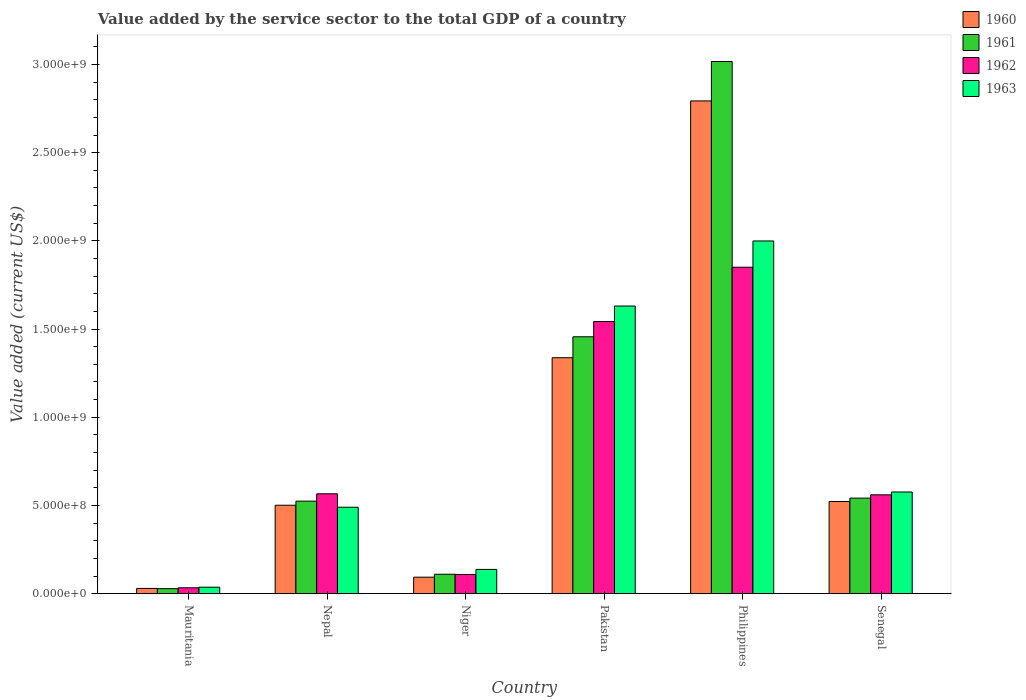How many different coloured bars are there?
Your response must be concise. 4. How many groups of bars are there?
Make the answer very short. 6. Are the number of bars per tick equal to the number of legend labels?
Your response must be concise. Yes. Are the number of bars on each tick of the X-axis equal?
Keep it short and to the point. Yes. How many bars are there on the 2nd tick from the right?
Ensure brevity in your answer.  4. In how many cases, is the number of bars for a given country not equal to the number of legend labels?
Ensure brevity in your answer.  0. What is the value added by the service sector to the total GDP in 1963 in Senegal?
Your answer should be very brief. 5.76e+08. Across all countries, what is the maximum value added by the service sector to the total GDP in 1961?
Ensure brevity in your answer.  3.02e+09. Across all countries, what is the minimum value added by the service sector to the total GDP in 1960?
Offer a terse response. 2.97e+07. In which country was the value added by the service sector to the total GDP in 1963 maximum?
Offer a very short reply. Philippines. In which country was the value added by the service sector to the total GDP in 1962 minimum?
Offer a terse response. Mauritania. What is the total value added by the service sector to the total GDP in 1962 in the graph?
Ensure brevity in your answer.  4.66e+09. What is the difference between the value added by the service sector to the total GDP in 1961 in Nepal and that in Niger?
Your answer should be compact. 4.14e+08. What is the difference between the value added by the service sector to the total GDP in 1961 in Philippines and the value added by the service sector to the total GDP in 1960 in Mauritania?
Provide a short and direct response. 2.99e+09. What is the average value added by the service sector to the total GDP in 1960 per country?
Offer a terse response. 8.80e+08. What is the difference between the value added by the service sector to the total GDP of/in 1960 and value added by the service sector to the total GDP of/in 1961 in Philippines?
Provide a short and direct response. -2.24e+08. In how many countries, is the value added by the service sector to the total GDP in 1962 greater than 1900000000 US$?
Keep it short and to the point. 0. What is the ratio of the value added by the service sector to the total GDP in 1960 in Mauritania to that in Philippines?
Offer a terse response. 0.01. Is the value added by the service sector to the total GDP in 1960 in Mauritania less than that in Nepal?
Keep it short and to the point. Yes. Is the difference between the value added by the service sector to the total GDP in 1960 in Niger and Pakistan greater than the difference between the value added by the service sector to the total GDP in 1961 in Niger and Pakistan?
Give a very brief answer. Yes. What is the difference between the highest and the second highest value added by the service sector to the total GDP in 1962?
Give a very brief answer. 1.28e+09. What is the difference between the highest and the lowest value added by the service sector to the total GDP in 1963?
Your answer should be compact. 1.96e+09. In how many countries, is the value added by the service sector to the total GDP in 1961 greater than the average value added by the service sector to the total GDP in 1961 taken over all countries?
Offer a very short reply. 2. Is the sum of the value added by the service sector to the total GDP in 1963 in Mauritania and Nepal greater than the maximum value added by the service sector to the total GDP in 1960 across all countries?
Your answer should be very brief. No. What does the 3rd bar from the right in Philippines represents?
Make the answer very short. 1961. Is it the case that in every country, the sum of the value added by the service sector to the total GDP in 1960 and value added by the service sector to the total GDP in 1961 is greater than the value added by the service sector to the total GDP in 1962?
Give a very brief answer. Yes. How many bars are there?
Provide a succinct answer. 24. Are all the bars in the graph horizontal?
Offer a terse response. No. How many countries are there in the graph?
Your answer should be compact. 6. What is the difference between two consecutive major ticks on the Y-axis?
Give a very brief answer. 5.00e+08. Are the values on the major ticks of Y-axis written in scientific E-notation?
Offer a very short reply. Yes. Does the graph contain grids?
Provide a succinct answer. No. What is the title of the graph?
Keep it short and to the point. Value added by the service sector to the total GDP of a country. Does "1988" appear as one of the legend labels in the graph?
Keep it short and to the point. No. What is the label or title of the Y-axis?
Ensure brevity in your answer.  Value added (current US$). What is the Value added (current US$) in 1960 in Mauritania?
Provide a short and direct response. 2.97e+07. What is the Value added (current US$) in 1961 in Mauritania?
Your answer should be very brief. 2.83e+07. What is the Value added (current US$) of 1962 in Mauritania?
Your answer should be compact. 3.32e+07. What is the Value added (current US$) in 1963 in Mauritania?
Ensure brevity in your answer.  3.67e+07. What is the Value added (current US$) of 1960 in Nepal?
Ensure brevity in your answer.  5.01e+08. What is the Value added (current US$) in 1961 in Nepal?
Provide a succinct answer. 5.25e+08. What is the Value added (current US$) of 1962 in Nepal?
Your response must be concise. 5.66e+08. What is the Value added (current US$) in 1963 in Nepal?
Give a very brief answer. 4.90e+08. What is the Value added (current US$) of 1960 in Niger?
Make the answer very short. 9.35e+07. What is the Value added (current US$) in 1961 in Niger?
Offer a terse response. 1.10e+08. What is the Value added (current US$) in 1962 in Niger?
Provide a short and direct response. 1.09e+08. What is the Value added (current US$) in 1963 in Niger?
Give a very brief answer. 1.37e+08. What is the Value added (current US$) of 1960 in Pakistan?
Make the answer very short. 1.34e+09. What is the Value added (current US$) of 1961 in Pakistan?
Keep it short and to the point. 1.46e+09. What is the Value added (current US$) of 1962 in Pakistan?
Your answer should be compact. 1.54e+09. What is the Value added (current US$) in 1963 in Pakistan?
Give a very brief answer. 1.63e+09. What is the Value added (current US$) in 1960 in Philippines?
Your answer should be very brief. 2.79e+09. What is the Value added (current US$) in 1961 in Philippines?
Offer a very short reply. 3.02e+09. What is the Value added (current US$) in 1962 in Philippines?
Provide a succinct answer. 1.85e+09. What is the Value added (current US$) of 1963 in Philippines?
Your answer should be compact. 2.00e+09. What is the Value added (current US$) of 1960 in Senegal?
Your answer should be very brief. 5.23e+08. What is the Value added (current US$) of 1961 in Senegal?
Make the answer very short. 5.42e+08. What is the Value added (current US$) in 1962 in Senegal?
Provide a succinct answer. 5.60e+08. What is the Value added (current US$) in 1963 in Senegal?
Your response must be concise. 5.76e+08. Across all countries, what is the maximum Value added (current US$) in 1960?
Offer a terse response. 2.79e+09. Across all countries, what is the maximum Value added (current US$) in 1961?
Your answer should be very brief. 3.02e+09. Across all countries, what is the maximum Value added (current US$) of 1962?
Make the answer very short. 1.85e+09. Across all countries, what is the maximum Value added (current US$) in 1963?
Your answer should be very brief. 2.00e+09. Across all countries, what is the minimum Value added (current US$) in 1960?
Give a very brief answer. 2.97e+07. Across all countries, what is the minimum Value added (current US$) of 1961?
Offer a very short reply. 2.83e+07. Across all countries, what is the minimum Value added (current US$) in 1962?
Keep it short and to the point. 3.32e+07. Across all countries, what is the minimum Value added (current US$) of 1963?
Your answer should be compact. 3.67e+07. What is the total Value added (current US$) in 1960 in the graph?
Your answer should be compact. 5.28e+09. What is the total Value added (current US$) of 1961 in the graph?
Your answer should be compact. 5.68e+09. What is the total Value added (current US$) in 1962 in the graph?
Make the answer very short. 4.66e+09. What is the total Value added (current US$) in 1963 in the graph?
Your answer should be compact. 4.87e+09. What is the difference between the Value added (current US$) of 1960 in Mauritania and that in Nepal?
Provide a short and direct response. -4.72e+08. What is the difference between the Value added (current US$) of 1961 in Mauritania and that in Nepal?
Provide a short and direct response. -4.96e+08. What is the difference between the Value added (current US$) of 1962 in Mauritania and that in Nepal?
Give a very brief answer. -5.33e+08. What is the difference between the Value added (current US$) of 1963 in Mauritania and that in Nepal?
Offer a very short reply. -4.53e+08. What is the difference between the Value added (current US$) of 1960 in Mauritania and that in Niger?
Ensure brevity in your answer.  -6.37e+07. What is the difference between the Value added (current US$) in 1961 in Mauritania and that in Niger?
Your answer should be compact. -8.18e+07. What is the difference between the Value added (current US$) in 1962 in Mauritania and that in Niger?
Your answer should be very brief. -7.57e+07. What is the difference between the Value added (current US$) of 1963 in Mauritania and that in Niger?
Your response must be concise. -1.01e+08. What is the difference between the Value added (current US$) of 1960 in Mauritania and that in Pakistan?
Offer a terse response. -1.31e+09. What is the difference between the Value added (current US$) in 1961 in Mauritania and that in Pakistan?
Provide a short and direct response. -1.43e+09. What is the difference between the Value added (current US$) in 1962 in Mauritania and that in Pakistan?
Your answer should be very brief. -1.51e+09. What is the difference between the Value added (current US$) in 1963 in Mauritania and that in Pakistan?
Offer a terse response. -1.59e+09. What is the difference between the Value added (current US$) of 1960 in Mauritania and that in Philippines?
Keep it short and to the point. -2.76e+09. What is the difference between the Value added (current US$) in 1961 in Mauritania and that in Philippines?
Your answer should be compact. -2.99e+09. What is the difference between the Value added (current US$) in 1962 in Mauritania and that in Philippines?
Give a very brief answer. -1.82e+09. What is the difference between the Value added (current US$) of 1963 in Mauritania and that in Philippines?
Offer a terse response. -1.96e+09. What is the difference between the Value added (current US$) of 1960 in Mauritania and that in Senegal?
Provide a succinct answer. -4.93e+08. What is the difference between the Value added (current US$) in 1961 in Mauritania and that in Senegal?
Your response must be concise. -5.13e+08. What is the difference between the Value added (current US$) of 1962 in Mauritania and that in Senegal?
Offer a very short reply. -5.27e+08. What is the difference between the Value added (current US$) in 1963 in Mauritania and that in Senegal?
Your answer should be compact. -5.40e+08. What is the difference between the Value added (current US$) of 1960 in Nepal and that in Niger?
Offer a very short reply. 4.08e+08. What is the difference between the Value added (current US$) of 1961 in Nepal and that in Niger?
Your answer should be very brief. 4.14e+08. What is the difference between the Value added (current US$) in 1962 in Nepal and that in Niger?
Give a very brief answer. 4.57e+08. What is the difference between the Value added (current US$) in 1963 in Nepal and that in Niger?
Make the answer very short. 3.53e+08. What is the difference between the Value added (current US$) in 1960 in Nepal and that in Pakistan?
Offer a terse response. -8.36e+08. What is the difference between the Value added (current US$) of 1961 in Nepal and that in Pakistan?
Your answer should be very brief. -9.32e+08. What is the difference between the Value added (current US$) of 1962 in Nepal and that in Pakistan?
Offer a very short reply. -9.77e+08. What is the difference between the Value added (current US$) in 1963 in Nepal and that in Pakistan?
Provide a succinct answer. -1.14e+09. What is the difference between the Value added (current US$) in 1960 in Nepal and that in Philippines?
Make the answer very short. -2.29e+09. What is the difference between the Value added (current US$) in 1961 in Nepal and that in Philippines?
Your answer should be compact. -2.49e+09. What is the difference between the Value added (current US$) in 1962 in Nepal and that in Philippines?
Make the answer very short. -1.28e+09. What is the difference between the Value added (current US$) in 1963 in Nepal and that in Philippines?
Ensure brevity in your answer.  -1.51e+09. What is the difference between the Value added (current US$) in 1960 in Nepal and that in Senegal?
Ensure brevity in your answer.  -2.14e+07. What is the difference between the Value added (current US$) in 1961 in Nepal and that in Senegal?
Your answer should be very brief. -1.70e+07. What is the difference between the Value added (current US$) in 1962 in Nepal and that in Senegal?
Ensure brevity in your answer.  5.71e+06. What is the difference between the Value added (current US$) in 1963 in Nepal and that in Senegal?
Offer a very short reply. -8.63e+07. What is the difference between the Value added (current US$) of 1960 in Niger and that in Pakistan?
Make the answer very short. -1.24e+09. What is the difference between the Value added (current US$) of 1961 in Niger and that in Pakistan?
Give a very brief answer. -1.35e+09. What is the difference between the Value added (current US$) of 1962 in Niger and that in Pakistan?
Offer a terse response. -1.43e+09. What is the difference between the Value added (current US$) of 1963 in Niger and that in Pakistan?
Offer a terse response. -1.49e+09. What is the difference between the Value added (current US$) in 1960 in Niger and that in Philippines?
Ensure brevity in your answer.  -2.70e+09. What is the difference between the Value added (current US$) of 1961 in Niger and that in Philippines?
Ensure brevity in your answer.  -2.91e+09. What is the difference between the Value added (current US$) in 1962 in Niger and that in Philippines?
Give a very brief answer. -1.74e+09. What is the difference between the Value added (current US$) of 1963 in Niger and that in Philippines?
Make the answer very short. -1.86e+09. What is the difference between the Value added (current US$) in 1960 in Niger and that in Senegal?
Your response must be concise. -4.29e+08. What is the difference between the Value added (current US$) of 1961 in Niger and that in Senegal?
Your answer should be compact. -4.32e+08. What is the difference between the Value added (current US$) in 1962 in Niger and that in Senegal?
Your answer should be very brief. -4.51e+08. What is the difference between the Value added (current US$) in 1963 in Niger and that in Senegal?
Provide a short and direct response. -4.39e+08. What is the difference between the Value added (current US$) in 1960 in Pakistan and that in Philippines?
Give a very brief answer. -1.46e+09. What is the difference between the Value added (current US$) in 1961 in Pakistan and that in Philippines?
Your answer should be very brief. -1.56e+09. What is the difference between the Value added (current US$) of 1962 in Pakistan and that in Philippines?
Offer a very short reply. -3.08e+08. What is the difference between the Value added (current US$) in 1963 in Pakistan and that in Philippines?
Offer a terse response. -3.69e+08. What is the difference between the Value added (current US$) of 1960 in Pakistan and that in Senegal?
Offer a terse response. 8.15e+08. What is the difference between the Value added (current US$) of 1961 in Pakistan and that in Senegal?
Ensure brevity in your answer.  9.15e+08. What is the difference between the Value added (current US$) in 1962 in Pakistan and that in Senegal?
Your answer should be very brief. 9.82e+08. What is the difference between the Value added (current US$) in 1963 in Pakistan and that in Senegal?
Your answer should be compact. 1.05e+09. What is the difference between the Value added (current US$) in 1960 in Philippines and that in Senegal?
Your answer should be compact. 2.27e+09. What is the difference between the Value added (current US$) in 1961 in Philippines and that in Senegal?
Ensure brevity in your answer.  2.48e+09. What is the difference between the Value added (current US$) in 1962 in Philippines and that in Senegal?
Make the answer very short. 1.29e+09. What is the difference between the Value added (current US$) of 1963 in Philippines and that in Senegal?
Your response must be concise. 1.42e+09. What is the difference between the Value added (current US$) of 1960 in Mauritania and the Value added (current US$) of 1961 in Nepal?
Provide a succinct answer. -4.95e+08. What is the difference between the Value added (current US$) in 1960 in Mauritania and the Value added (current US$) in 1962 in Nepal?
Your response must be concise. -5.36e+08. What is the difference between the Value added (current US$) of 1960 in Mauritania and the Value added (current US$) of 1963 in Nepal?
Your answer should be compact. -4.60e+08. What is the difference between the Value added (current US$) in 1961 in Mauritania and the Value added (current US$) in 1962 in Nepal?
Provide a succinct answer. -5.38e+08. What is the difference between the Value added (current US$) in 1961 in Mauritania and the Value added (current US$) in 1963 in Nepal?
Keep it short and to the point. -4.62e+08. What is the difference between the Value added (current US$) of 1962 in Mauritania and the Value added (current US$) of 1963 in Nepal?
Provide a short and direct response. -4.57e+08. What is the difference between the Value added (current US$) of 1960 in Mauritania and the Value added (current US$) of 1961 in Niger?
Make the answer very short. -8.04e+07. What is the difference between the Value added (current US$) of 1960 in Mauritania and the Value added (current US$) of 1962 in Niger?
Provide a short and direct response. -7.92e+07. What is the difference between the Value added (current US$) in 1960 in Mauritania and the Value added (current US$) in 1963 in Niger?
Your answer should be compact. -1.08e+08. What is the difference between the Value added (current US$) of 1961 in Mauritania and the Value added (current US$) of 1962 in Niger?
Offer a very short reply. -8.06e+07. What is the difference between the Value added (current US$) in 1961 in Mauritania and the Value added (current US$) in 1963 in Niger?
Provide a succinct answer. -1.09e+08. What is the difference between the Value added (current US$) of 1962 in Mauritania and the Value added (current US$) of 1963 in Niger?
Make the answer very short. -1.04e+08. What is the difference between the Value added (current US$) in 1960 in Mauritania and the Value added (current US$) in 1961 in Pakistan?
Offer a very short reply. -1.43e+09. What is the difference between the Value added (current US$) in 1960 in Mauritania and the Value added (current US$) in 1962 in Pakistan?
Keep it short and to the point. -1.51e+09. What is the difference between the Value added (current US$) in 1960 in Mauritania and the Value added (current US$) in 1963 in Pakistan?
Your response must be concise. -1.60e+09. What is the difference between the Value added (current US$) of 1961 in Mauritania and the Value added (current US$) of 1962 in Pakistan?
Ensure brevity in your answer.  -1.51e+09. What is the difference between the Value added (current US$) of 1961 in Mauritania and the Value added (current US$) of 1963 in Pakistan?
Give a very brief answer. -1.60e+09. What is the difference between the Value added (current US$) of 1962 in Mauritania and the Value added (current US$) of 1963 in Pakistan?
Offer a very short reply. -1.60e+09. What is the difference between the Value added (current US$) of 1960 in Mauritania and the Value added (current US$) of 1961 in Philippines?
Your answer should be compact. -2.99e+09. What is the difference between the Value added (current US$) in 1960 in Mauritania and the Value added (current US$) in 1962 in Philippines?
Make the answer very short. -1.82e+09. What is the difference between the Value added (current US$) in 1960 in Mauritania and the Value added (current US$) in 1963 in Philippines?
Offer a terse response. -1.97e+09. What is the difference between the Value added (current US$) of 1961 in Mauritania and the Value added (current US$) of 1962 in Philippines?
Keep it short and to the point. -1.82e+09. What is the difference between the Value added (current US$) of 1961 in Mauritania and the Value added (current US$) of 1963 in Philippines?
Provide a succinct answer. -1.97e+09. What is the difference between the Value added (current US$) of 1962 in Mauritania and the Value added (current US$) of 1963 in Philippines?
Your answer should be very brief. -1.97e+09. What is the difference between the Value added (current US$) in 1960 in Mauritania and the Value added (current US$) in 1961 in Senegal?
Offer a terse response. -5.12e+08. What is the difference between the Value added (current US$) of 1960 in Mauritania and the Value added (current US$) of 1962 in Senegal?
Your answer should be compact. -5.31e+08. What is the difference between the Value added (current US$) of 1960 in Mauritania and the Value added (current US$) of 1963 in Senegal?
Give a very brief answer. -5.47e+08. What is the difference between the Value added (current US$) in 1961 in Mauritania and the Value added (current US$) in 1962 in Senegal?
Keep it short and to the point. -5.32e+08. What is the difference between the Value added (current US$) of 1961 in Mauritania and the Value added (current US$) of 1963 in Senegal?
Offer a very short reply. -5.48e+08. What is the difference between the Value added (current US$) in 1962 in Mauritania and the Value added (current US$) in 1963 in Senegal?
Provide a short and direct response. -5.43e+08. What is the difference between the Value added (current US$) of 1960 in Nepal and the Value added (current US$) of 1961 in Niger?
Your response must be concise. 3.91e+08. What is the difference between the Value added (current US$) in 1960 in Nepal and the Value added (current US$) in 1962 in Niger?
Offer a very short reply. 3.92e+08. What is the difference between the Value added (current US$) of 1960 in Nepal and the Value added (current US$) of 1963 in Niger?
Give a very brief answer. 3.64e+08. What is the difference between the Value added (current US$) of 1961 in Nepal and the Value added (current US$) of 1962 in Niger?
Provide a succinct answer. 4.16e+08. What is the difference between the Value added (current US$) of 1961 in Nepal and the Value added (current US$) of 1963 in Niger?
Your response must be concise. 3.87e+08. What is the difference between the Value added (current US$) in 1962 in Nepal and the Value added (current US$) in 1963 in Niger?
Offer a terse response. 4.29e+08. What is the difference between the Value added (current US$) in 1960 in Nepal and the Value added (current US$) in 1961 in Pakistan?
Provide a succinct answer. -9.55e+08. What is the difference between the Value added (current US$) of 1960 in Nepal and the Value added (current US$) of 1962 in Pakistan?
Your answer should be very brief. -1.04e+09. What is the difference between the Value added (current US$) of 1960 in Nepal and the Value added (current US$) of 1963 in Pakistan?
Provide a short and direct response. -1.13e+09. What is the difference between the Value added (current US$) of 1961 in Nepal and the Value added (current US$) of 1962 in Pakistan?
Give a very brief answer. -1.02e+09. What is the difference between the Value added (current US$) in 1961 in Nepal and the Value added (current US$) in 1963 in Pakistan?
Ensure brevity in your answer.  -1.11e+09. What is the difference between the Value added (current US$) in 1962 in Nepal and the Value added (current US$) in 1963 in Pakistan?
Keep it short and to the point. -1.06e+09. What is the difference between the Value added (current US$) of 1960 in Nepal and the Value added (current US$) of 1961 in Philippines?
Offer a terse response. -2.52e+09. What is the difference between the Value added (current US$) in 1960 in Nepal and the Value added (current US$) in 1962 in Philippines?
Your answer should be compact. -1.35e+09. What is the difference between the Value added (current US$) of 1960 in Nepal and the Value added (current US$) of 1963 in Philippines?
Offer a terse response. -1.50e+09. What is the difference between the Value added (current US$) of 1961 in Nepal and the Value added (current US$) of 1962 in Philippines?
Give a very brief answer. -1.33e+09. What is the difference between the Value added (current US$) of 1961 in Nepal and the Value added (current US$) of 1963 in Philippines?
Your response must be concise. -1.47e+09. What is the difference between the Value added (current US$) of 1962 in Nepal and the Value added (current US$) of 1963 in Philippines?
Keep it short and to the point. -1.43e+09. What is the difference between the Value added (current US$) of 1960 in Nepal and the Value added (current US$) of 1961 in Senegal?
Offer a very short reply. -4.04e+07. What is the difference between the Value added (current US$) in 1960 in Nepal and the Value added (current US$) in 1962 in Senegal?
Make the answer very short. -5.91e+07. What is the difference between the Value added (current US$) of 1960 in Nepal and the Value added (current US$) of 1963 in Senegal?
Keep it short and to the point. -7.51e+07. What is the difference between the Value added (current US$) in 1961 in Nepal and the Value added (current US$) in 1962 in Senegal?
Provide a short and direct response. -3.58e+07. What is the difference between the Value added (current US$) of 1961 in Nepal and the Value added (current US$) of 1963 in Senegal?
Provide a succinct answer. -5.18e+07. What is the difference between the Value added (current US$) in 1962 in Nepal and the Value added (current US$) in 1963 in Senegal?
Provide a succinct answer. -1.03e+07. What is the difference between the Value added (current US$) in 1960 in Niger and the Value added (current US$) in 1961 in Pakistan?
Your answer should be very brief. -1.36e+09. What is the difference between the Value added (current US$) of 1960 in Niger and the Value added (current US$) of 1962 in Pakistan?
Offer a terse response. -1.45e+09. What is the difference between the Value added (current US$) in 1960 in Niger and the Value added (current US$) in 1963 in Pakistan?
Your response must be concise. -1.54e+09. What is the difference between the Value added (current US$) of 1961 in Niger and the Value added (current US$) of 1962 in Pakistan?
Offer a terse response. -1.43e+09. What is the difference between the Value added (current US$) in 1961 in Niger and the Value added (current US$) in 1963 in Pakistan?
Give a very brief answer. -1.52e+09. What is the difference between the Value added (current US$) in 1962 in Niger and the Value added (current US$) in 1963 in Pakistan?
Make the answer very short. -1.52e+09. What is the difference between the Value added (current US$) of 1960 in Niger and the Value added (current US$) of 1961 in Philippines?
Your response must be concise. -2.92e+09. What is the difference between the Value added (current US$) in 1960 in Niger and the Value added (current US$) in 1962 in Philippines?
Ensure brevity in your answer.  -1.76e+09. What is the difference between the Value added (current US$) of 1960 in Niger and the Value added (current US$) of 1963 in Philippines?
Keep it short and to the point. -1.91e+09. What is the difference between the Value added (current US$) in 1961 in Niger and the Value added (current US$) in 1962 in Philippines?
Make the answer very short. -1.74e+09. What is the difference between the Value added (current US$) in 1961 in Niger and the Value added (current US$) in 1963 in Philippines?
Provide a succinct answer. -1.89e+09. What is the difference between the Value added (current US$) in 1962 in Niger and the Value added (current US$) in 1963 in Philippines?
Your answer should be compact. -1.89e+09. What is the difference between the Value added (current US$) in 1960 in Niger and the Value added (current US$) in 1961 in Senegal?
Keep it short and to the point. -4.48e+08. What is the difference between the Value added (current US$) of 1960 in Niger and the Value added (current US$) of 1962 in Senegal?
Your answer should be very brief. -4.67e+08. What is the difference between the Value added (current US$) of 1960 in Niger and the Value added (current US$) of 1963 in Senegal?
Give a very brief answer. -4.83e+08. What is the difference between the Value added (current US$) of 1961 in Niger and the Value added (current US$) of 1962 in Senegal?
Provide a short and direct response. -4.50e+08. What is the difference between the Value added (current US$) in 1961 in Niger and the Value added (current US$) in 1963 in Senegal?
Provide a succinct answer. -4.66e+08. What is the difference between the Value added (current US$) in 1962 in Niger and the Value added (current US$) in 1963 in Senegal?
Your answer should be compact. -4.67e+08. What is the difference between the Value added (current US$) in 1960 in Pakistan and the Value added (current US$) in 1961 in Philippines?
Give a very brief answer. -1.68e+09. What is the difference between the Value added (current US$) in 1960 in Pakistan and the Value added (current US$) in 1962 in Philippines?
Provide a short and direct response. -5.13e+08. What is the difference between the Value added (current US$) in 1960 in Pakistan and the Value added (current US$) in 1963 in Philippines?
Provide a succinct answer. -6.62e+08. What is the difference between the Value added (current US$) of 1961 in Pakistan and the Value added (current US$) of 1962 in Philippines?
Offer a terse response. -3.94e+08. What is the difference between the Value added (current US$) in 1961 in Pakistan and the Value added (current US$) in 1963 in Philippines?
Provide a short and direct response. -5.43e+08. What is the difference between the Value added (current US$) in 1962 in Pakistan and the Value added (current US$) in 1963 in Philippines?
Provide a succinct answer. -4.57e+08. What is the difference between the Value added (current US$) of 1960 in Pakistan and the Value added (current US$) of 1961 in Senegal?
Your response must be concise. 7.96e+08. What is the difference between the Value added (current US$) in 1960 in Pakistan and the Value added (current US$) in 1962 in Senegal?
Keep it short and to the point. 7.77e+08. What is the difference between the Value added (current US$) of 1960 in Pakistan and the Value added (current US$) of 1963 in Senegal?
Your answer should be very brief. 7.61e+08. What is the difference between the Value added (current US$) of 1961 in Pakistan and the Value added (current US$) of 1962 in Senegal?
Your response must be concise. 8.96e+08. What is the difference between the Value added (current US$) in 1961 in Pakistan and the Value added (current US$) in 1963 in Senegal?
Offer a very short reply. 8.80e+08. What is the difference between the Value added (current US$) in 1962 in Pakistan and the Value added (current US$) in 1963 in Senegal?
Provide a succinct answer. 9.66e+08. What is the difference between the Value added (current US$) in 1960 in Philippines and the Value added (current US$) in 1961 in Senegal?
Ensure brevity in your answer.  2.25e+09. What is the difference between the Value added (current US$) in 1960 in Philippines and the Value added (current US$) in 1962 in Senegal?
Your answer should be very brief. 2.23e+09. What is the difference between the Value added (current US$) in 1960 in Philippines and the Value added (current US$) in 1963 in Senegal?
Offer a terse response. 2.22e+09. What is the difference between the Value added (current US$) in 1961 in Philippines and the Value added (current US$) in 1962 in Senegal?
Offer a terse response. 2.46e+09. What is the difference between the Value added (current US$) in 1961 in Philippines and the Value added (current US$) in 1963 in Senegal?
Offer a very short reply. 2.44e+09. What is the difference between the Value added (current US$) of 1962 in Philippines and the Value added (current US$) of 1963 in Senegal?
Provide a succinct answer. 1.27e+09. What is the average Value added (current US$) of 1960 per country?
Offer a very short reply. 8.80e+08. What is the average Value added (current US$) in 1961 per country?
Offer a terse response. 9.46e+08. What is the average Value added (current US$) of 1962 per country?
Provide a short and direct response. 7.77e+08. What is the average Value added (current US$) of 1963 per country?
Your answer should be compact. 8.12e+08. What is the difference between the Value added (current US$) of 1960 and Value added (current US$) of 1961 in Mauritania?
Make the answer very short. 1.42e+06. What is the difference between the Value added (current US$) in 1960 and Value added (current US$) in 1962 in Mauritania?
Ensure brevity in your answer.  -3.51e+06. What is the difference between the Value added (current US$) in 1960 and Value added (current US$) in 1963 in Mauritania?
Provide a succinct answer. -6.94e+06. What is the difference between the Value added (current US$) in 1961 and Value added (current US$) in 1962 in Mauritania?
Ensure brevity in your answer.  -4.93e+06. What is the difference between the Value added (current US$) in 1961 and Value added (current US$) in 1963 in Mauritania?
Offer a very short reply. -8.35e+06. What is the difference between the Value added (current US$) in 1962 and Value added (current US$) in 1963 in Mauritania?
Make the answer very short. -3.42e+06. What is the difference between the Value added (current US$) in 1960 and Value added (current US$) in 1961 in Nepal?
Your answer should be very brief. -2.34e+07. What is the difference between the Value added (current US$) in 1960 and Value added (current US$) in 1962 in Nepal?
Ensure brevity in your answer.  -6.48e+07. What is the difference between the Value added (current US$) in 1960 and Value added (current US$) in 1963 in Nepal?
Keep it short and to the point. 1.12e+07. What is the difference between the Value added (current US$) of 1961 and Value added (current US$) of 1962 in Nepal?
Provide a short and direct response. -4.15e+07. What is the difference between the Value added (current US$) in 1961 and Value added (current US$) in 1963 in Nepal?
Your response must be concise. 3.46e+07. What is the difference between the Value added (current US$) of 1962 and Value added (current US$) of 1963 in Nepal?
Keep it short and to the point. 7.60e+07. What is the difference between the Value added (current US$) of 1960 and Value added (current US$) of 1961 in Niger?
Keep it short and to the point. -1.67e+07. What is the difference between the Value added (current US$) of 1960 and Value added (current US$) of 1962 in Niger?
Provide a short and direct response. -1.55e+07. What is the difference between the Value added (current US$) in 1960 and Value added (current US$) in 1963 in Niger?
Offer a terse response. -4.40e+07. What is the difference between the Value added (current US$) in 1961 and Value added (current US$) in 1962 in Niger?
Your answer should be very brief. 1.20e+06. What is the difference between the Value added (current US$) of 1961 and Value added (current US$) of 1963 in Niger?
Keep it short and to the point. -2.73e+07. What is the difference between the Value added (current US$) in 1962 and Value added (current US$) in 1963 in Niger?
Provide a short and direct response. -2.85e+07. What is the difference between the Value added (current US$) of 1960 and Value added (current US$) of 1961 in Pakistan?
Offer a terse response. -1.19e+08. What is the difference between the Value added (current US$) of 1960 and Value added (current US$) of 1962 in Pakistan?
Make the answer very short. -2.05e+08. What is the difference between the Value added (current US$) of 1960 and Value added (current US$) of 1963 in Pakistan?
Provide a succinct answer. -2.93e+08. What is the difference between the Value added (current US$) in 1961 and Value added (current US$) in 1962 in Pakistan?
Ensure brevity in your answer.  -8.63e+07. What is the difference between the Value added (current US$) in 1961 and Value added (current US$) in 1963 in Pakistan?
Offer a very short reply. -1.74e+08. What is the difference between the Value added (current US$) in 1962 and Value added (current US$) in 1963 in Pakistan?
Give a very brief answer. -8.80e+07. What is the difference between the Value added (current US$) of 1960 and Value added (current US$) of 1961 in Philippines?
Provide a succinct answer. -2.24e+08. What is the difference between the Value added (current US$) in 1960 and Value added (current US$) in 1962 in Philippines?
Keep it short and to the point. 9.43e+08. What is the difference between the Value added (current US$) in 1960 and Value added (current US$) in 1963 in Philippines?
Make the answer very short. 7.94e+08. What is the difference between the Value added (current US$) in 1961 and Value added (current US$) in 1962 in Philippines?
Provide a short and direct response. 1.17e+09. What is the difference between the Value added (current US$) in 1961 and Value added (current US$) in 1963 in Philippines?
Your answer should be compact. 1.02e+09. What is the difference between the Value added (current US$) in 1962 and Value added (current US$) in 1963 in Philippines?
Provide a short and direct response. -1.49e+08. What is the difference between the Value added (current US$) of 1960 and Value added (current US$) of 1961 in Senegal?
Offer a terse response. -1.90e+07. What is the difference between the Value added (current US$) of 1960 and Value added (current US$) of 1962 in Senegal?
Keep it short and to the point. -3.77e+07. What is the difference between the Value added (current US$) of 1960 and Value added (current US$) of 1963 in Senegal?
Keep it short and to the point. -5.38e+07. What is the difference between the Value added (current US$) of 1961 and Value added (current US$) of 1962 in Senegal?
Give a very brief answer. -1.87e+07. What is the difference between the Value added (current US$) in 1961 and Value added (current US$) in 1963 in Senegal?
Provide a succinct answer. -3.48e+07. What is the difference between the Value added (current US$) of 1962 and Value added (current US$) of 1963 in Senegal?
Your answer should be very brief. -1.60e+07. What is the ratio of the Value added (current US$) in 1960 in Mauritania to that in Nepal?
Offer a terse response. 0.06. What is the ratio of the Value added (current US$) in 1961 in Mauritania to that in Nepal?
Offer a terse response. 0.05. What is the ratio of the Value added (current US$) of 1962 in Mauritania to that in Nepal?
Your answer should be compact. 0.06. What is the ratio of the Value added (current US$) in 1963 in Mauritania to that in Nepal?
Your answer should be compact. 0.07. What is the ratio of the Value added (current US$) of 1960 in Mauritania to that in Niger?
Your answer should be very brief. 0.32. What is the ratio of the Value added (current US$) of 1961 in Mauritania to that in Niger?
Offer a very short reply. 0.26. What is the ratio of the Value added (current US$) in 1962 in Mauritania to that in Niger?
Provide a short and direct response. 0.31. What is the ratio of the Value added (current US$) in 1963 in Mauritania to that in Niger?
Your answer should be very brief. 0.27. What is the ratio of the Value added (current US$) in 1960 in Mauritania to that in Pakistan?
Offer a very short reply. 0.02. What is the ratio of the Value added (current US$) of 1961 in Mauritania to that in Pakistan?
Offer a terse response. 0.02. What is the ratio of the Value added (current US$) of 1962 in Mauritania to that in Pakistan?
Give a very brief answer. 0.02. What is the ratio of the Value added (current US$) in 1963 in Mauritania to that in Pakistan?
Provide a short and direct response. 0.02. What is the ratio of the Value added (current US$) of 1960 in Mauritania to that in Philippines?
Keep it short and to the point. 0.01. What is the ratio of the Value added (current US$) in 1961 in Mauritania to that in Philippines?
Your response must be concise. 0.01. What is the ratio of the Value added (current US$) of 1962 in Mauritania to that in Philippines?
Your answer should be compact. 0.02. What is the ratio of the Value added (current US$) of 1963 in Mauritania to that in Philippines?
Your answer should be very brief. 0.02. What is the ratio of the Value added (current US$) in 1960 in Mauritania to that in Senegal?
Keep it short and to the point. 0.06. What is the ratio of the Value added (current US$) in 1961 in Mauritania to that in Senegal?
Ensure brevity in your answer.  0.05. What is the ratio of the Value added (current US$) of 1962 in Mauritania to that in Senegal?
Provide a short and direct response. 0.06. What is the ratio of the Value added (current US$) in 1963 in Mauritania to that in Senegal?
Your answer should be very brief. 0.06. What is the ratio of the Value added (current US$) in 1960 in Nepal to that in Niger?
Offer a terse response. 5.36. What is the ratio of the Value added (current US$) in 1961 in Nepal to that in Niger?
Ensure brevity in your answer.  4.76. What is the ratio of the Value added (current US$) of 1962 in Nepal to that in Niger?
Give a very brief answer. 5.2. What is the ratio of the Value added (current US$) in 1963 in Nepal to that in Niger?
Give a very brief answer. 3.57. What is the ratio of the Value added (current US$) in 1960 in Nepal to that in Pakistan?
Ensure brevity in your answer.  0.37. What is the ratio of the Value added (current US$) in 1961 in Nepal to that in Pakistan?
Provide a succinct answer. 0.36. What is the ratio of the Value added (current US$) in 1962 in Nepal to that in Pakistan?
Provide a succinct answer. 0.37. What is the ratio of the Value added (current US$) in 1963 in Nepal to that in Pakistan?
Provide a short and direct response. 0.3. What is the ratio of the Value added (current US$) in 1960 in Nepal to that in Philippines?
Provide a succinct answer. 0.18. What is the ratio of the Value added (current US$) in 1961 in Nepal to that in Philippines?
Provide a succinct answer. 0.17. What is the ratio of the Value added (current US$) of 1962 in Nepal to that in Philippines?
Give a very brief answer. 0.31. What is the ratio of the Value added (current US$) in 1963 in Nepal to that in Philippines?
Make the answer very short. 0.25. What is the ratio of the Value added (current US$) in 1960 in Nepal to that in Senegal?
Provide a short and direct response. 0.96. What is the ratio of the Value added (current US$) in 1961 in Nepal to that in Senegal?
Provide a succinct answer. 0.97. What is the ratio of the Value added (current US$) of 1962 in Nepal to that in Senegal?
Ensure brevity in your answer.  1.01. What is the ratio of the Value added (current US$) of 1963 in Nepal to that in Senegal?
Offer a terse response. 0.85. What is the ratio of the Value added (current US$) of 1960 in Niger to that in Pakistan?
Make the answer very short. 0.07. What is the ratio of the Value added (current US$) of 1961 in Niger to that in Pakistan?
Your response must be concise. 0.08. What is the ratio of the Value added (current US$) of 1962 in Niger to that in Pakistan?
Your response must be concise. 0.07. What is the ratio of the Value added (current US$) of 1963 in Niger to that in Pakistan?
Offer a very short reply. 0.08. What is the ratio of the Value added (current US$) of 1960 in Niger to that in Philippines?
Provide a short and direct response. 0.03. What is the ratio of the Value added (current US$) of 1961 in Niger to that in Philippines?
Give a very brief answer. 0.04. What is the ratio of the Value added (current US$) in 1962 in Niger to that in Philippines?
Keep it short and to the point. 0.06. What is the ratio of the Value added (current US$) of 1963 in Niger to that in Philippines?
Give a very brief answer. 0.07. What is the ratio of the Value added (current US$) in 1960 in Niger to that in Senegal?
Give a very brief answer. 0.18. What is the ratio of the Value added (current US$) of 1961 in Niger to that in Senegal?
Your response must be concise. 0.2. What is the ratio of the Value added (current US$) in 1962 in Niger to that in Senegal?
Provide a short and direct response. 0.19. What is the ratio of the Value added (current US$) in 1963 in Niger to that in Senegal?
Give a very brief answer. 0.24. What is the ratio of the Value added (current US$) in 1960 in Pakistan to that in Philippines?
Offer a very short reply. 0.48. What is the ratio of the Value added (current US$) of 1961 in Pakistan to that in Philippines?
Your answer should be very brief. 0.48. What is the ratio of the Value added (current US$) of 1962 in Pakistan to that in Philippines?
Your response must be concise. 0.83. What is the ratio of the Value added (current US$) in 1963 in Pakistan to that in Philippines?
Provide a succinct answer. 0.82. What is the ratio of the Value added (current US$) in 1960 in Pakistan to that in Senegal?
Keep it short and to the point. 2.56. What is the ratio of the Value added (current US$) in 1961 in Pakistan to that in Senegal?
Offer a terse response. 2.69. What is the ratio of the Value added (current US$) of 1962 in Pakistan to that in Senegal?
Provide a short and direct response. 2.75. What is the ratio of the Value added (current US$) in 1963 in Pakistan to that in Senegal?
Give a very brief answer. 2.83. What is the ratio of the Value added (current US$) in 1960 in Philippines to that in Senegal?
Your answer should be very brief. 5.35. What is the ratio of the Value added (current US$) of 1961 in Philippines to that in Senegal?
Provide a short and direct response. 5.57. What is the ratio of the Value added (current US$) of 1962 in Philippines to that in Senegal?
Offer a terse response. 3.3. What is the ratio of the Value added (current US$) of 1963 in Philippines to that in Senegal?
Ensure brevity in your answer.  3.47. What is the difference between the highest and the second highest Value added (current US$) of 1960?
Provide a short and direct response. 1.46e+09. What is the difference between the highest and the second highest Value added (current US$) of 1961?
Give a very brief answer. 1.56e+09. What is the difference between the highest and the second highest Value added (current US$) in 1962?
Your answer should be compact. 3.08e+08. What is the difference between the highest and the second highest Value added (current US$) of 1963?
Make the answer very short. 3.69e+08. What is the difference between the highest and the lowest Value added (current US$) of 1960?
Give a very brief answer. 2.76e+09. What is the difference between the highest and the lowest Value added (current US$) of 1961?
Provide a short and direct response. 2.99e+09. What is the difference between the highest and the lowest Value added (current US$) in 1962?
Provide a succinct answer. 1.82e+09. What is the difference between the highest and the lowest Value added (current US$) of 1963?
Offer a very short reply. 1.96e+09. 